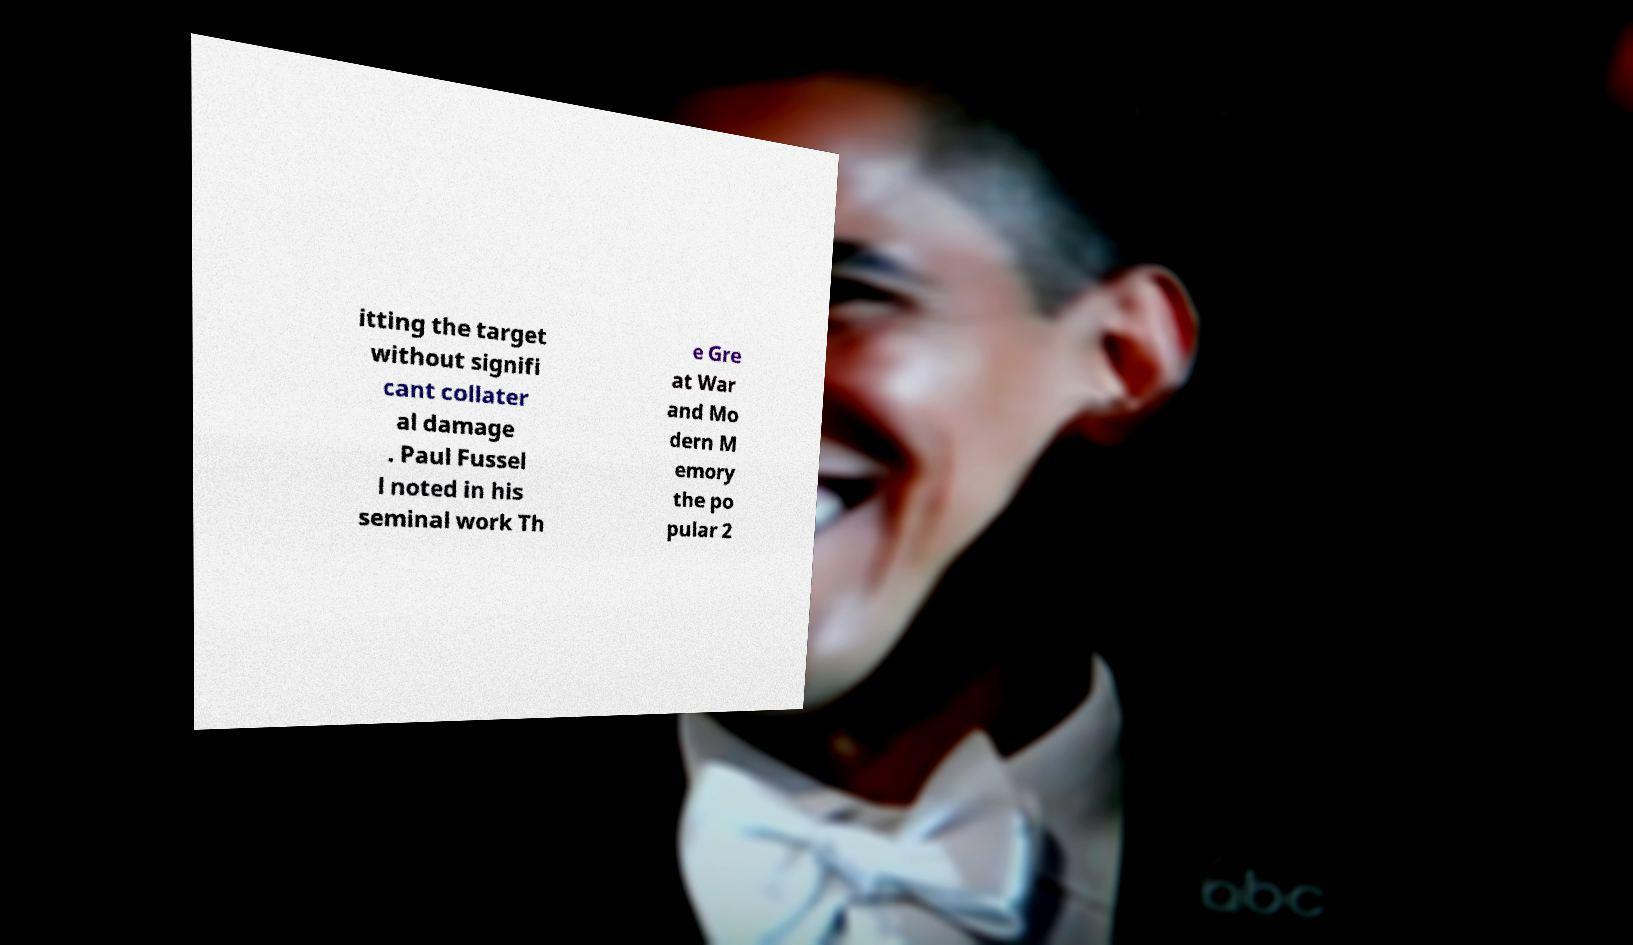Could you assist in decoding the text presented in this image and type it out clearly? itting the target without signifi cant collater al damage . Paul Fussel l noted in his seminal work Th e Gre at War and Mo dern M emory the po pular 2 